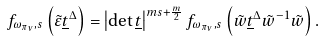<formula> <loc_0><loc_0><loc_500><loc_500>f _ { \omega _ { \pi _ { \nu } } , s } \left ( \tilde { \varepsilon } \underline { t } ^ { \Delta } \right ) = \left | \det \underline { t } \right | ^ { m s + \frac { m } { 2 } } f _ { \omega _ { \pi _ { \nu } } , s } \left ( \tilde { w } \underline { t } ^ { \Delta } \tilde { w } ^ { - 1 } \tilde { w } \right ) .</formula> 